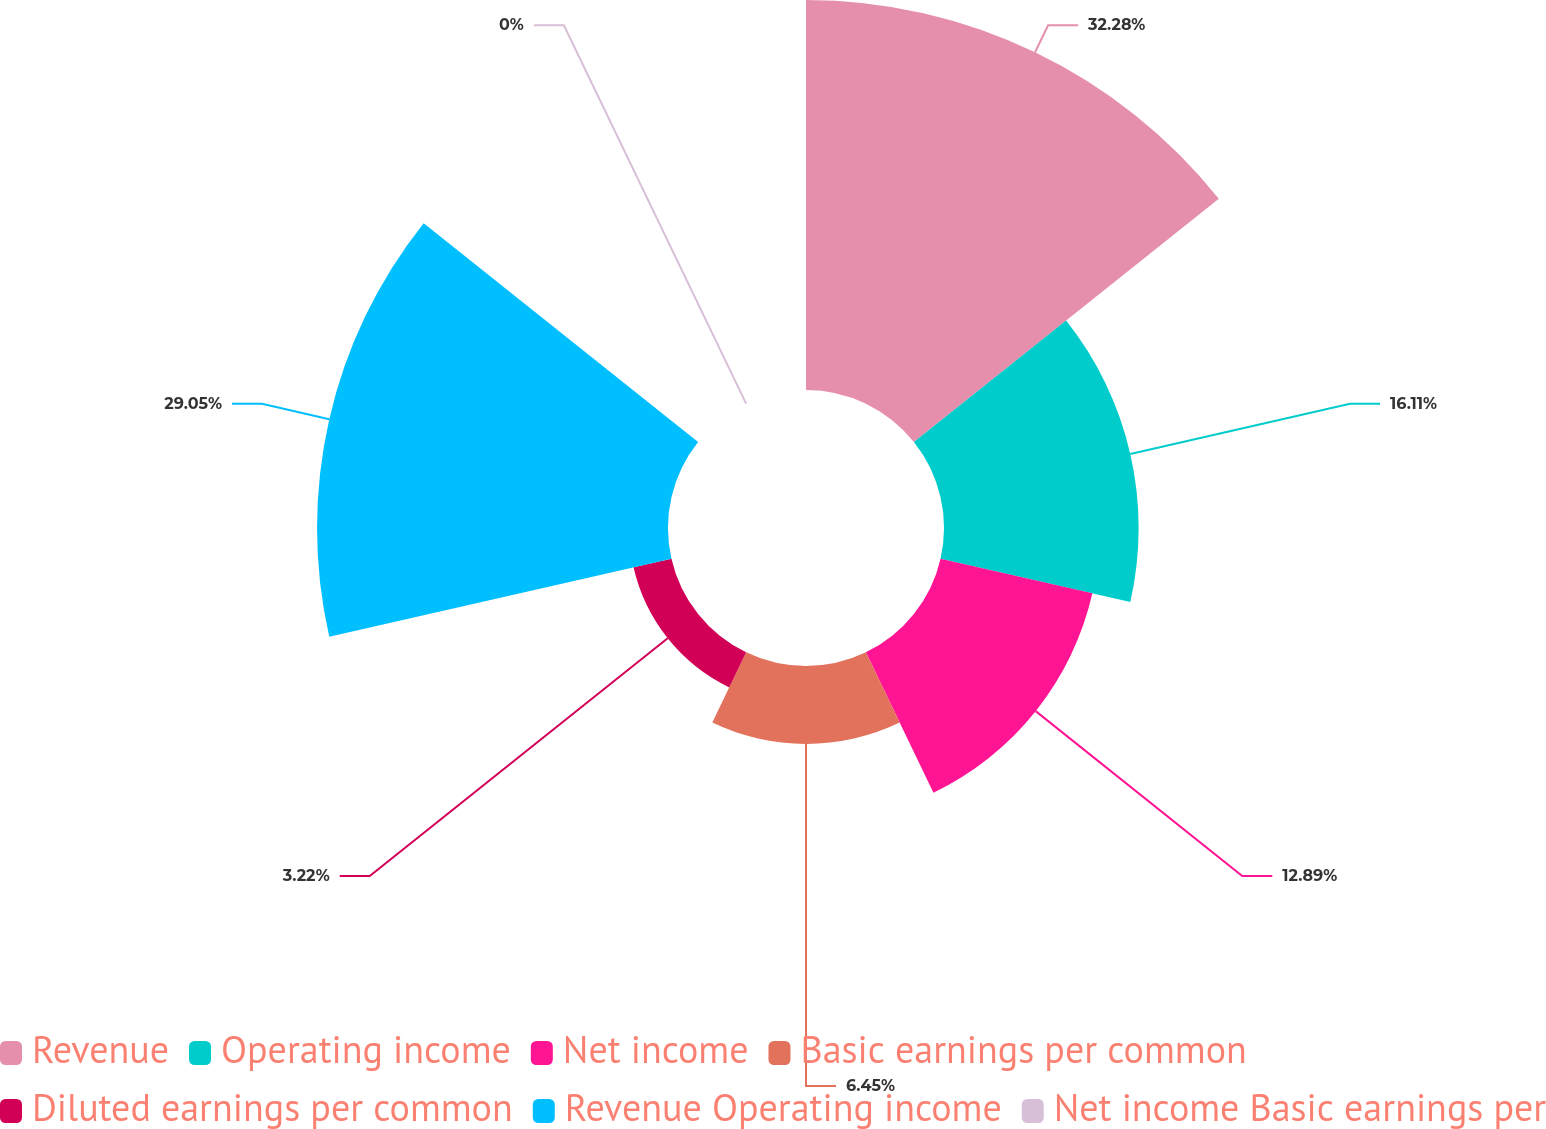<chart> <loc_0><loc_0><loc_500><loc_500><pie_chart><fcel>Revenue<fcel>Operating income<fcel>Net income<fcel>Basic earnings per common<fcel>Diluted earnings per common<fcel>Revenue Operating income<fcel>Net income Basic earnings per<nl><fcel>32.28%<fcel>16.11%<fcel>12.89%<fcel>6.45%<fcel>3.22%<fcel>29.05%<fcel>0.0%<nl></chart> 